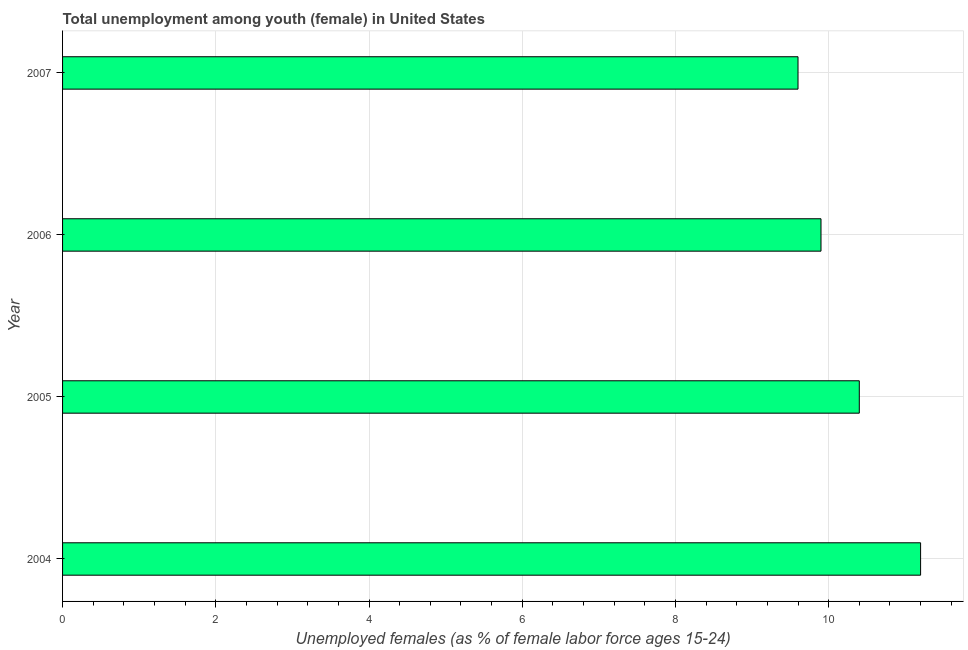What is the title of the graph?
Ensure brevity in your answer.  Total unemployment among youth (female) in United States. What is the label or title of the X-axis?
Your answer should be compact. Unemployed females (as % of female labor force ages 15-24). What is the unemployed female youth population in 2006?
Give a very brief answer. 9.9. Across all years, what is the maximum unemployed female youth population?
Offer a very short reply. 11.2. Across all years, what is the minimum unemployed female youth population?
Give a very brief answer. 9.6. What is the sum of the unemployed female youth population?
Offer a terse response. 41.1. What is the difference between the unemployed female youth population in 2006 and 2007?
Give a very brief answer. 0.3. What is the average unemployed female youth population per year?
Your answer should be compact. 10.28. What is the median unemployed female youth population?
Provide a succinct answer. 10.15. What is the ratio of the unemployed female youth population in 2004 to that in 2007?
Ensure brevity in your answer.  1.17. Is the unemployed female youth population in 2004 less than that in 2006?
Provide a short and direct response. No. Is the difference between the unemployed female youth population in 2006 and 2007 greater than the difference between any two years?
Give a very brief answer. No. In how many years, is the unemployed female youth population greater than the average unemployed female youth population taken over all years?
Provide a short and direct response. 2. What is the Unemployed females (as % of female labor force ages 15-24) in 2004?
Give a very brief answer. 11.2. What is the Unemployed females (as % of female labor force ages 15-24) in 2005?
Keep it short and to the point. 10.4. What is the Unemployed females (as % of female labor force ages 15-24) in 2006?
Offer a terse response. 9.9. What is the Unemployed females (as % of female labor force ages 15-24) of 2007?
Ensure brevity in your answer.  9.6. What is the difference between the Unemployed females (as % of female labor force ages 15-24) in 2004 and 2006?
Provide a short and direct response. 1.3. What is the difference between the Unemployed females (as % of female labor force ages 15-24) in 2004 and 2007?
Provide a succinct answer. 1.6. What is the difference between the Unemployed females (as % of female labor force ages 15-24) in 2005 and 2007?
Your answer should be compact. 0.8. What is the ratio of the Unemployed females (as % of female labor force ages 15-24) in 2004 to that in 2005?
Your answer should be very brief. 1.08. What is the ratio of the Unemployed females (as % of female labor force ages 15-24) in 2004 to that in 2006?
Make the answer very short. 1.13. What is the ratio of the Unemployed females (as % of female labor force ages 15-24) in 2004 to that in 2007?
Offer a very short reply. 1.17. What is the ratio of the Unemployed females (as % of female labor force ages 15-24) in 2005 to that in 2006?
Your answer should be very brief. 1.05. What is the ratio of the Unemployed females (as % of female labor force ages 15-24) in 2005 to that in 2007?
Make the answer very short. 1.08. What is the ratio of the Unemployed females (as % of female labor force ages 15-24) in 2006 to that in 2007?
Provide a short and direct response. 1.03. 